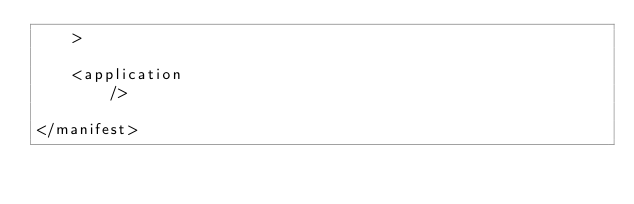Convert code to text. <code><loc_0><loc_0><loc_500><loc_500><_XML_>    >

    <application
        />

</manifest></code> 